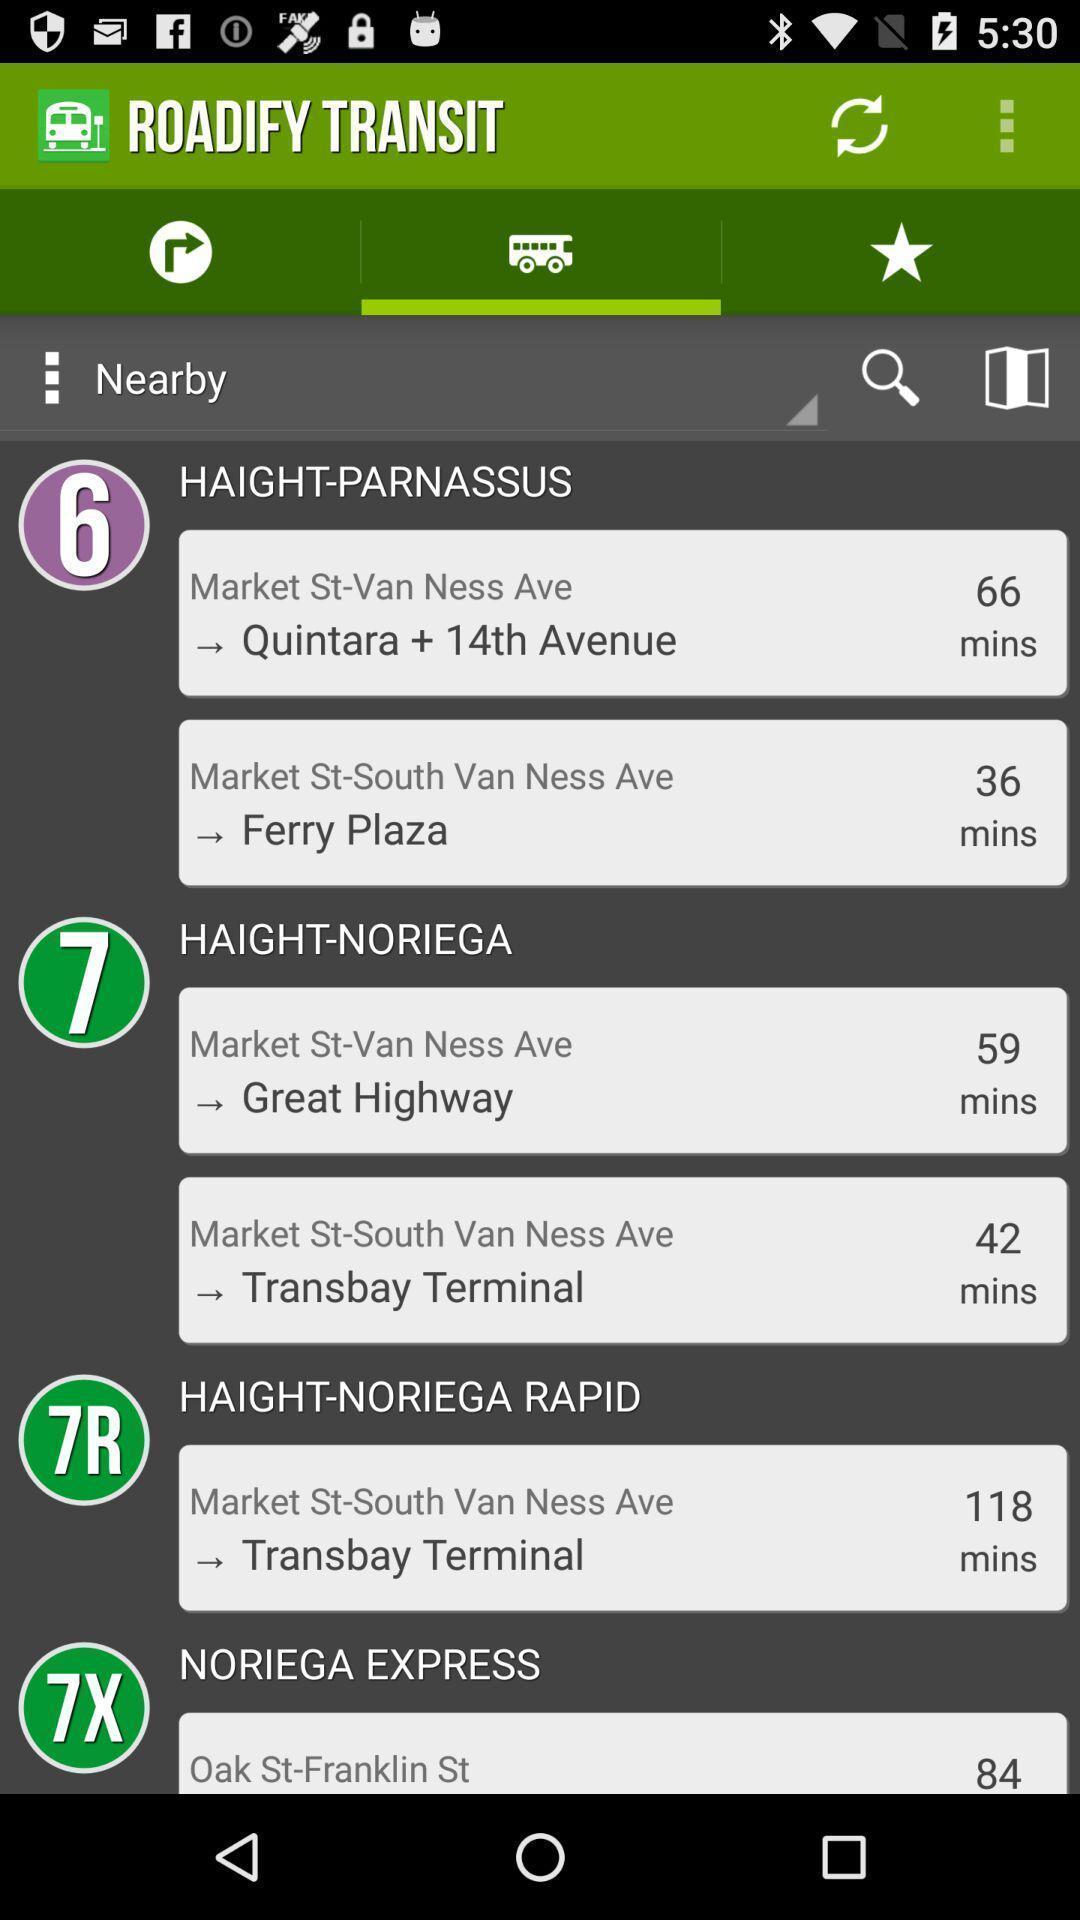Summarize the information in this screenshot. Page showing bus numbers for near by places in application. 